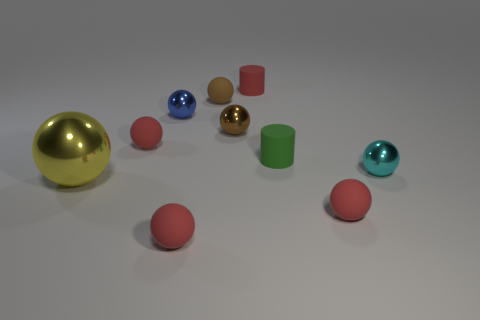Do the big object and the green object have the same material?
Give a very brief answer. No. There is a blue ball that is the same size as the red cylinder; what is it made of?
Offer a very short reply. Metal. What number of things are either brown matte objects left of the red matte cylinder or small gray balls?
Give a very brief answer. 1. Is the number of brown matte spheres that are on the right side of the large ball the same as the number of small cyan spheres?
Your answer should be compact. Yes. What is the color of the tiny thing that is right of the green matte cylinder and in front of the big metallic thing?
Provide a short and direct response. Red. What number of cylinders are small red things or small blue shiny things?
Give a very brief answer. 1. Is the number of small cyan metal balls that are on the right side of the big yellow object less than the number of large green metallic objects?
Offer a terse response. No. The tiny green object that is the same material as the red cylinder is what shape?
Ensure brevity in your answer.  Cylinder. How many objects are green matte cylinders or red balls?
Offer a very short reply. 4. What is the material of the small red ball that is behind the large yellow metal ball that is to the left of the blue shiny object?
Make the answer very short. Rubber. 